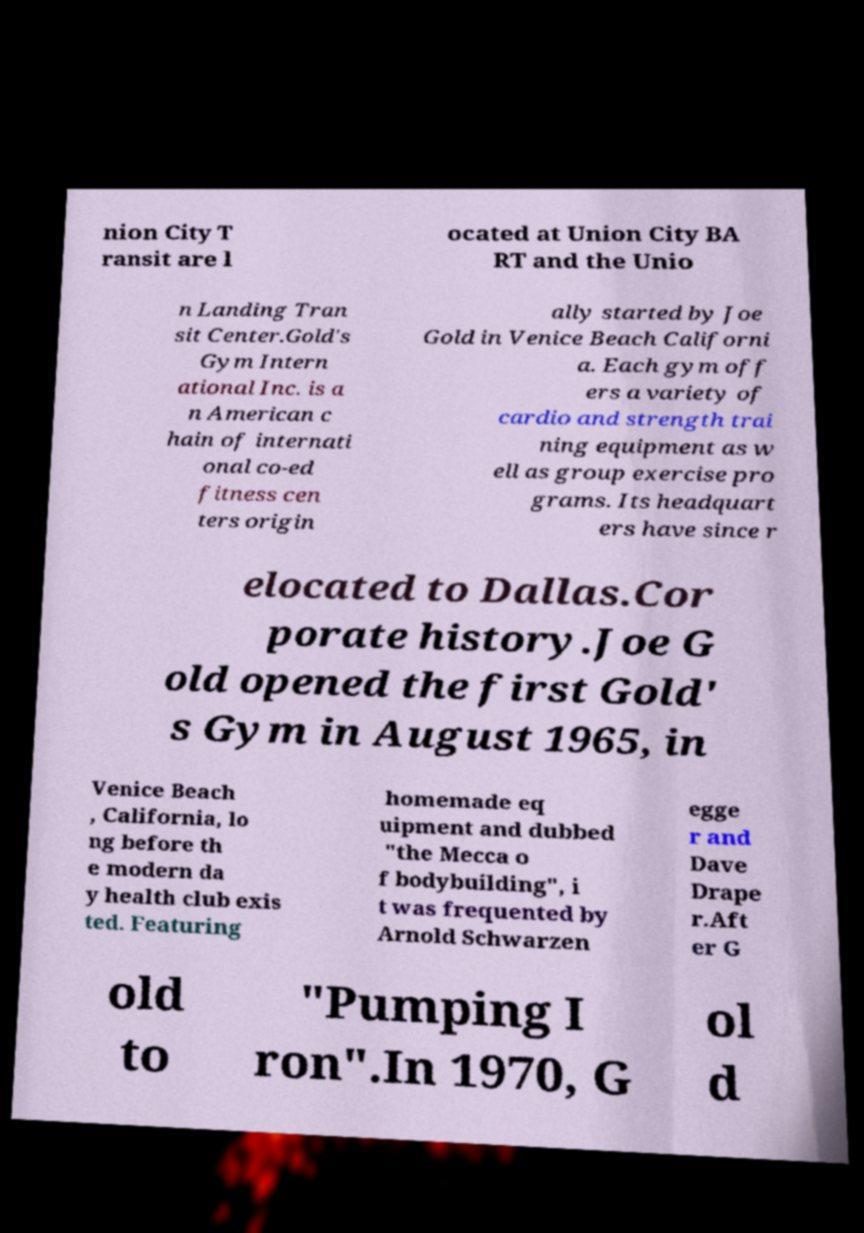Can you accurately transcribe the text from the provided image for me? nion City T ransit are l ocated at Union City BA RT and the Unio n Landing Tran sit Center.Gold's Gym Intern ational Inc. is a n American c hain of internati onal co-ed fitness cen ters origin ally started by Joe Gold in Venice Beach Californi a. Each gym off ers a variety of cardio and strength trai ning equipment as w ell as group exercise pro grams. Its headquart ers have since r elocated to Dallas.Cor porate history.Joe G old opened the first Gold' s Gym in August 1965, in Venice Beach , California, lo ng before th e modern da y health club exis ted. Featuring homemade eq uipment and dubbed "the Mecca o f bodybuilding", i t was frequented by Arnold Schwarzen egge r and Dave Drape r.Aft er G old to "Pumping I ron".In 1970, G ol d 